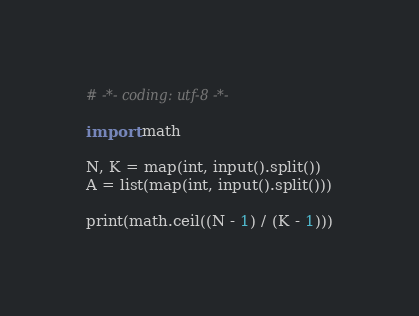<code> <loc_0><loc_0><loc_500><loc_500><_Python_># -*- coding: utf-8 -*-

import math

N, K = map(int, input().split())
A = list(map(int, input().split()))

print(math.ceil((N - 1) / (K - 1)))
</code> 